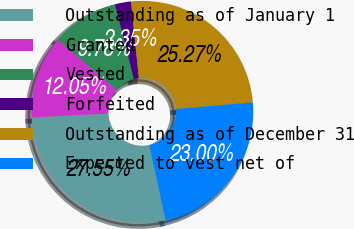Convert chart to OTSL. <chart><loc_0><loc_0><loc_500><loc_500><pie_chart><fcel>Outstanding as of January 1<fcel>Granted<fcel>Vested<fcel>Forfeited<fcel>Outstanding as of December 31<fcel>Expected to vest net of<nl><fcel>27.55%<fcel>12.05%<fcel>9.78%<fcel>2.35%<fcel>25.27%<fcel>23.0%<nl></chart> 